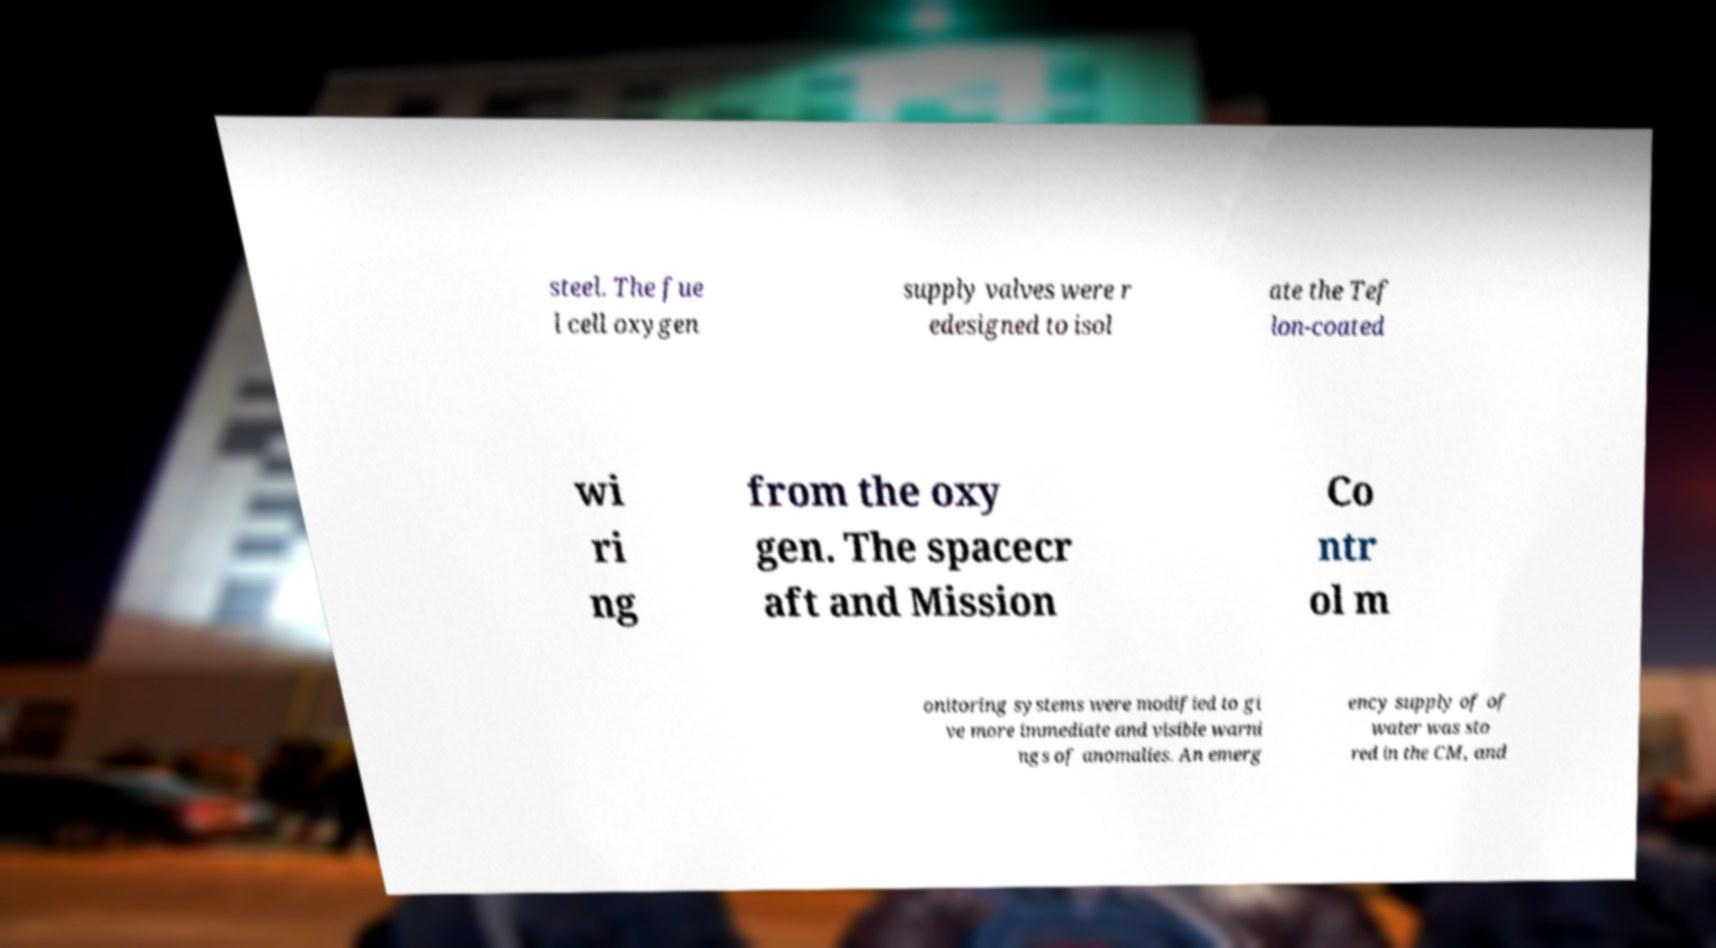Can you accurately transcribe the text from the provided image for me? steel. The fue l cell oxygen supply valves were r edesigned to isol ate the Tef lon-coated wi ri ng from the oxy gen. The spacecr aft and Mission Co ntr ol m onitoring systems were modified to gi ve more immediate and visible warni ngs of anomalies. An emerg ency supply of of water was sto red in the CM, and 